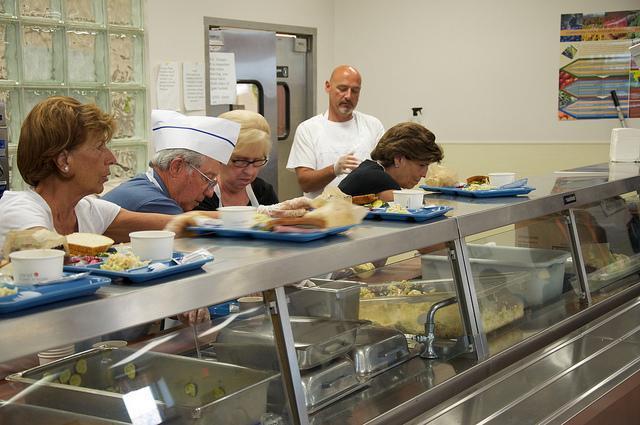How many workers are there?
Give a very brief answer. 5. How many people are there?
Give a very brief answer. 5. How many of the cows in this picture are chocolate brown?
Give a very brief answer. 0. 